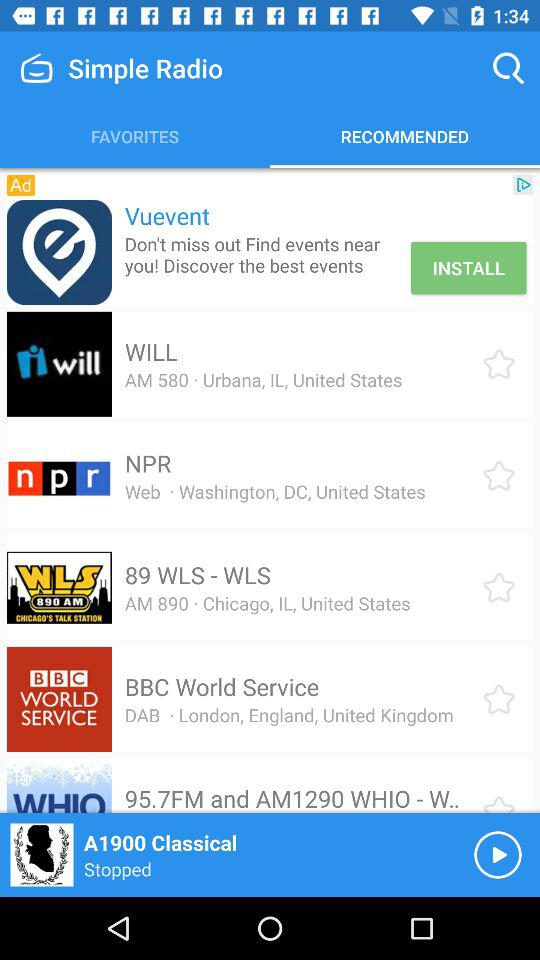What is the address of "89 WLS" radio station? The address of "89 WLS" radio station is Chicago, IL, United States. 